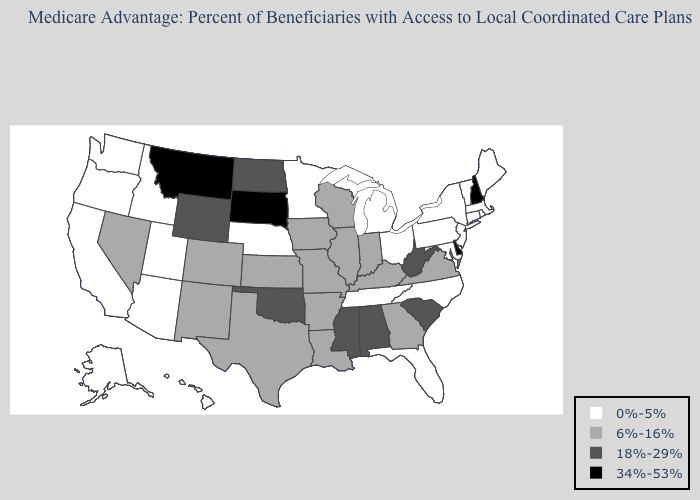What is the value of North Dakota?
Short answer required. 18%-29%. What is the lowest value in the South?
Answer briefly. 0%-5%. Is the legend a continuous bar?
Give a very brief answer. No. Does the first symbol in the legend represent the smallest category?
Be succinct. Yes. Name the states that have a value in the range 34%-53%?
Quick response, please. Delaware, Montana, New Hampshire, South Dakota. Does Vermont have the highest value in the Northeast?
Be succinct. No. What is the value of Alabama?
Concise answer only. 18%-29%. Name the states that have a value in the range 6%-16%?
Keep it brief. Arkansas, Colorado, Georgia, Iowa, Illinois, Indiana, Kansas, Kentucky, Louisiana, Missouri, New Mexico, Nevada, Texas, Virginia, Wisconsin. What is the highest value in the USA?
Give a very brief answer. 34%-53%. What is the lowest value in the MidWest?
Be succinct. 0%-5%. What is the lowest value in the USA?
Keep it brief. 0%-5%. What is the lowest value in the West?
Write a very short answer. 0%-5%. Which states hav the highest value in the West?
Short answer required. Montana. What is the lowest value in the Northeast?
Write a very short answer. 0%-5%. Among the states that border Tennessee , which have the lowest value?
Short answer required. North Carolina. 